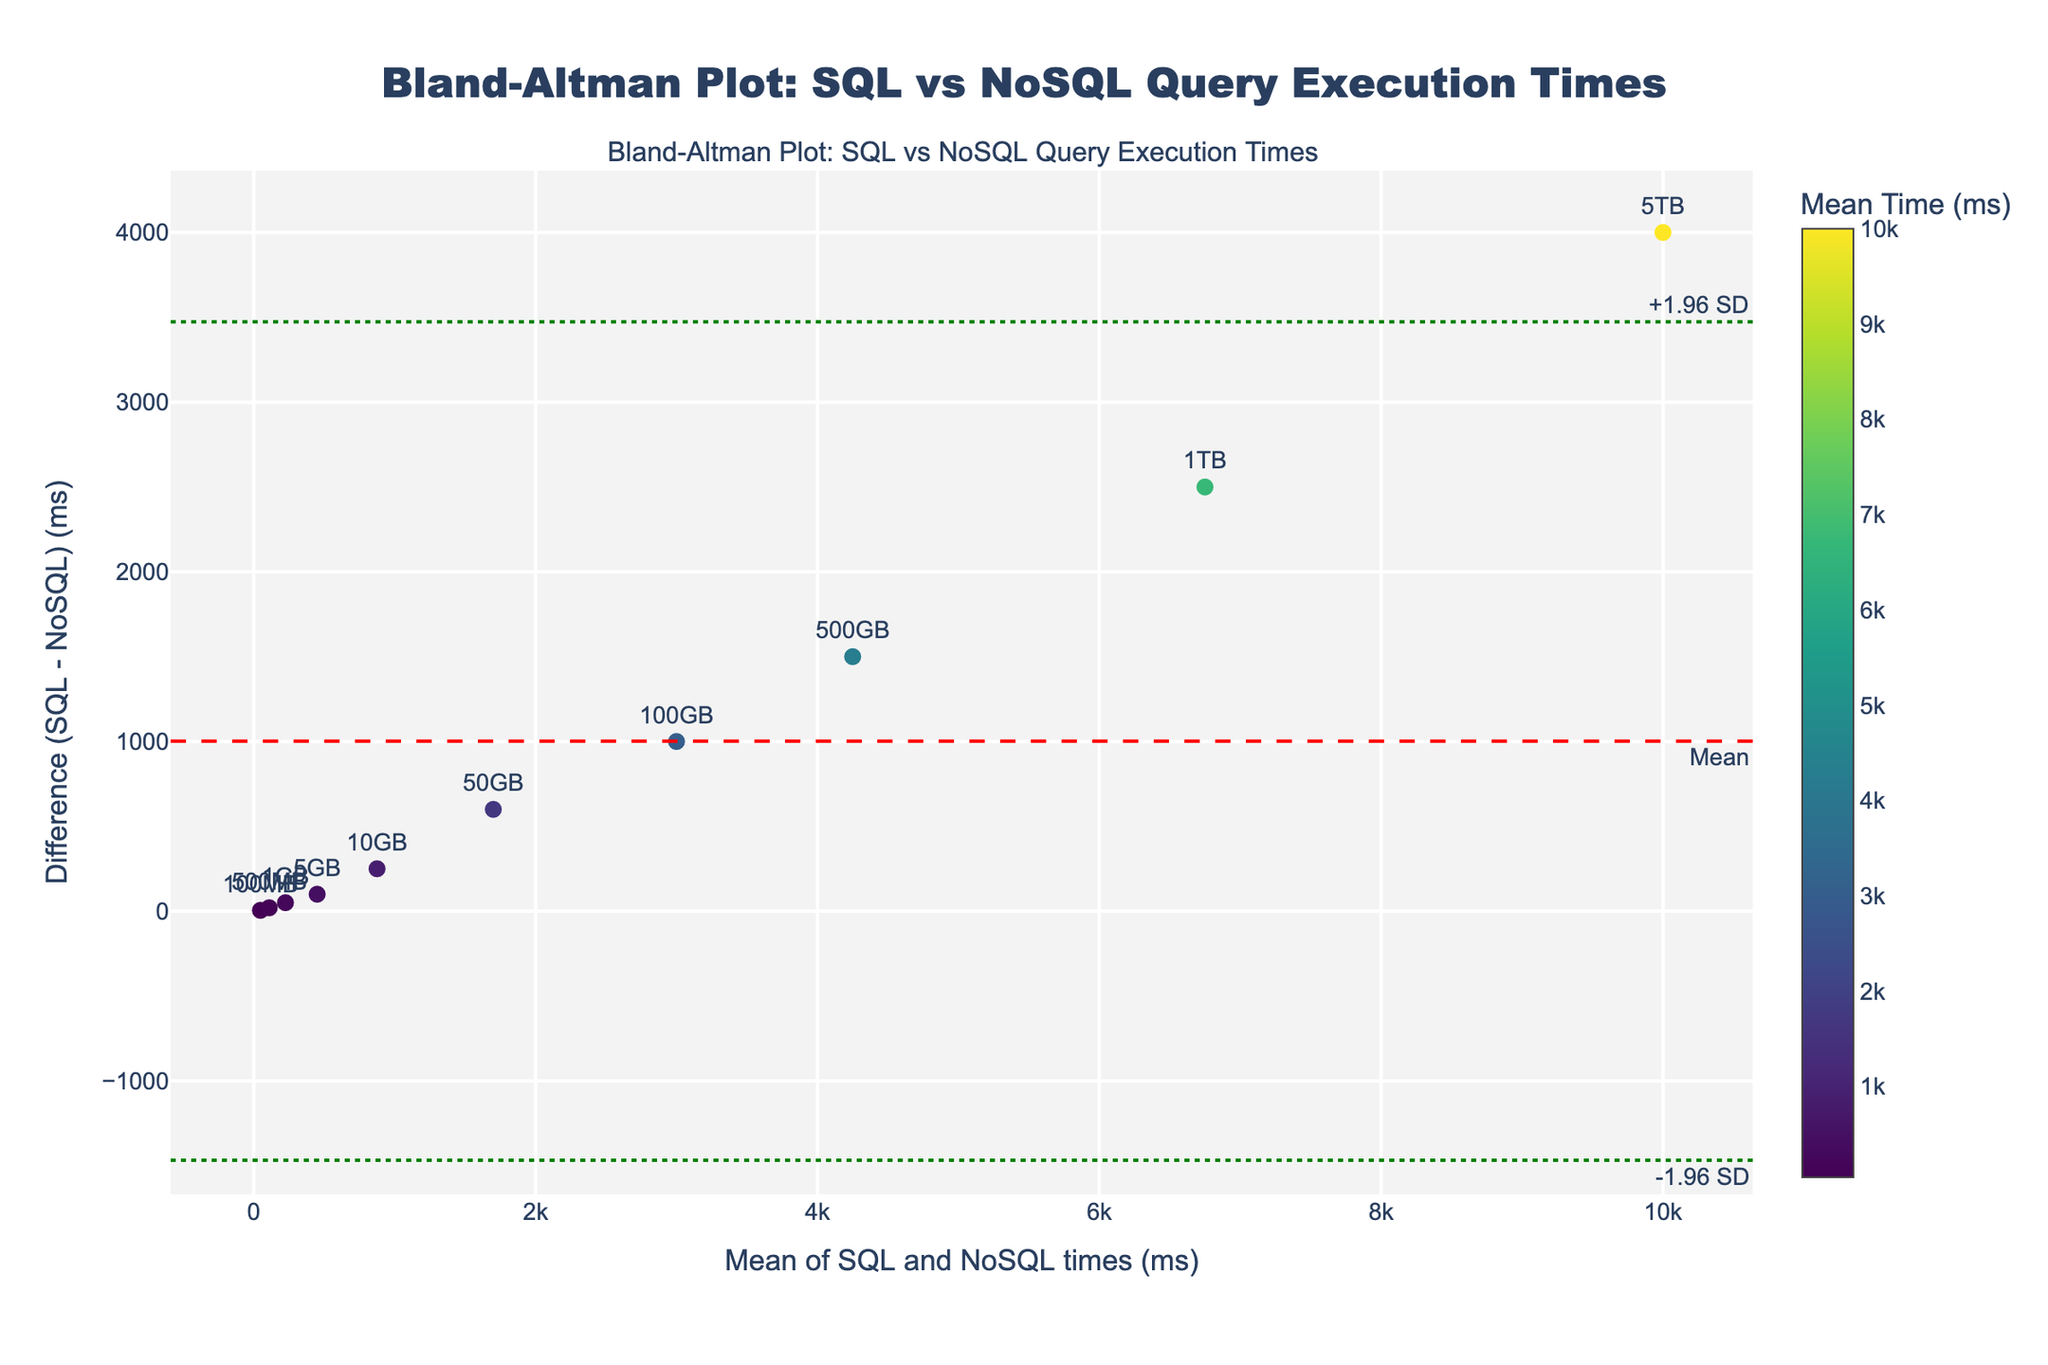what is the title of the plot? The title is usually found at the top of the plot and gives an overview of what the plot represents. In this case, the title is "Bland-Altman Plot: SQL vs NoSQL Query Execution Times".
Answer: Bland-Altman Plot: SQL vs NoSQL Query Execution Times How many data points are shown in the plot? Each data point typically represents a combination of SQL and NoSQL execution times for a specific data size. The number of data sizes listed (100MB, 500MB, 1GB, etc.) indicates there are 10 data points.
Answer: 10 What does the y-axis represent? The y-axis shows the difference between the SQL time and the NoSQL time, meaning it represents (SQL_time - NoSQL_time) in milliseconds.
Answer: Difference (SQL - NoSQL) (ms) What is the mean difference between SQL and NoSQL times? The mean difference is usually indicated by a dashed red horizontal line and a corresponding annotation. In this plot, the mean difference is marked.
Answer: mean difference What do the green dotted lines represent? The green dotted lines represent the limits of agreement, which are calculated as the mean difference plus and minus 1.96 times the standard deviation of the differences.
Answer: Limits of agreement (+1.96 SD and -1.96 SD) For which data size is the difference between SQL and NoSQL times the greatest? By looking at the y-axis values and the corresponding data size labels, the greatest difference occurs at the point farthest from the x-axis. For 5TB, the SQL time is much greater than the NoSQL time, leading to the largest difference.
Answer: 5TB Which data point corresponds to a mean execution time of around 10,000 ms? The mean execution time can be found on the x-axis. The data point closest to 10,000 ms is labeled 5TB.
Answer: 5TB What is the execution time difference for the smallest data size? The smallest data size is 100MB. Look at the point labeled 100MB on the plot and check its y-axis value to find the difference between SQL and NoSQL times.
Answer: Approximately 5 ms Is there a trend in differences as data size increases? Observing the scatter of points from left to right on the x-axis (increasing data sizes) and their corresponding y-axis values (differences), it appears that the difference tends to increase as the data size increases.
Answer: Yes, the difference increases with data size 